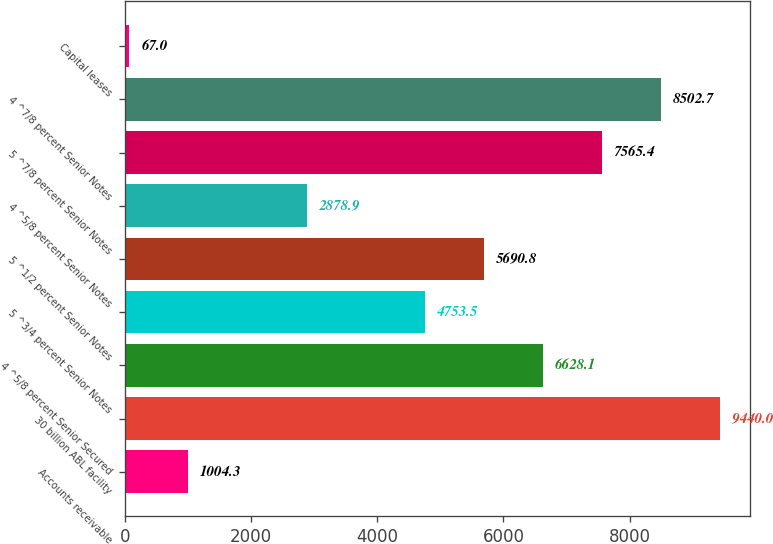Convert chart to OTSL. <chart><loc_0><loc_0><loc_500><loc_500><bar_chart><fcel>Accounts receivable<fcel>30 billion ABL facility<fcel>4 ^5/8 percent Senior Secured<fcel>5 ^3/4 percent Senior Notes<fcel>5 ^1/2 percent Senior Notes<fcel>4 ^5/8 percent Senior Notes<fcel>5 ^7/8 percent Senior Notes<fcel>4 ^7/8 percent Senior Notes<fcel>Capital leases<nl><fcel>1004.3<fcel>9440<fcel>6628.1<fcel>4753.5<fcel>5690.8<fcel>2878.9<fcel>7565.4<fcel>8502.7<fcel>67<nl></chart> 